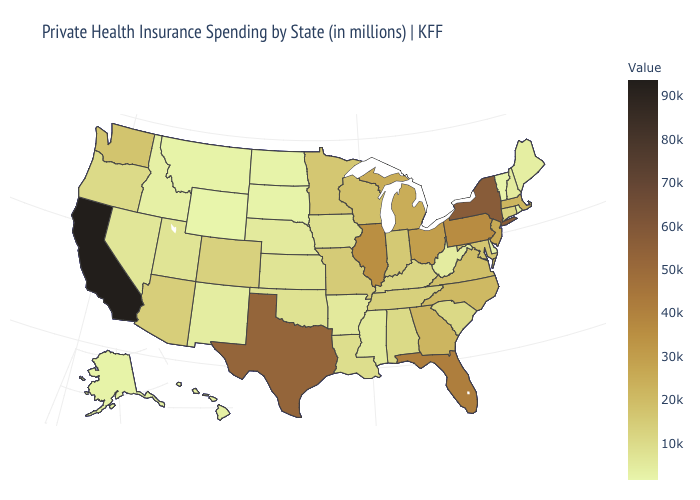Among the states that border South Carolina , which have the highest value?
Be succinct. Georgia. Which states have the lowest value in the South?
Be succinct. Delaware. Among the states that border Maine , which have the lowest value?
Give a very brief answer. New Hampshire. Does Texas have the highest value in the South?
Keep it brief. Yes. Does Kansas have the lowest value in the USA?
Keep it brief. No. Among the states that border South Dakota , does Wyoming have the lowest value?
Keep it brief. Yes. 